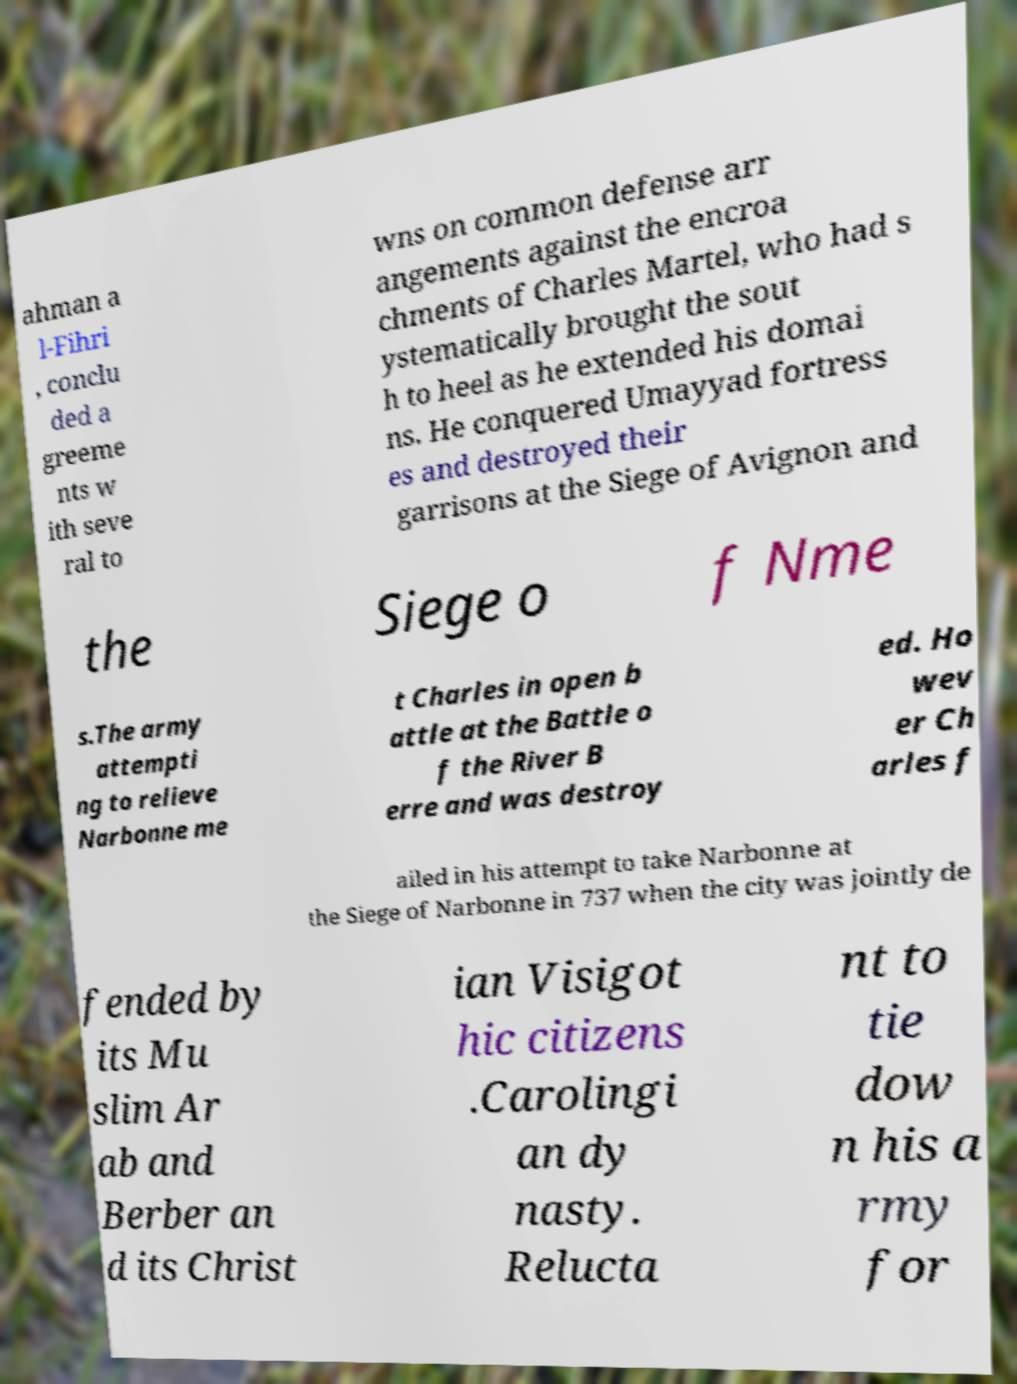Please read and relay the text visible in this image. What does it say? ahman a l-Fihri , conclu ded a greeme nts w ith seve ral to wns on common defense arr angements against the encroa chments of Charles Martel, who had s ystematically brought the sout h to heel as he extended his domai ns. He conquered Umayyad fortress es and destroyed their garrisons at the Siege of Avignon and the Siege o f Nme s.The army attempti ng to relieve Narbonne me t Charles in open b attle at the Battle o f the River B erre and was destroy ed. Ho wev er Ch arles f ailed in his attempt to take Narbonne at the Siege of Narbonne in 737 when the city was jointly de fended by its Mu slim Ar ab and Berber an d its Christ ian Visigot hic citizens .Carolingi an dy nasty. Relucta nt to tie dow n his a rmy for 